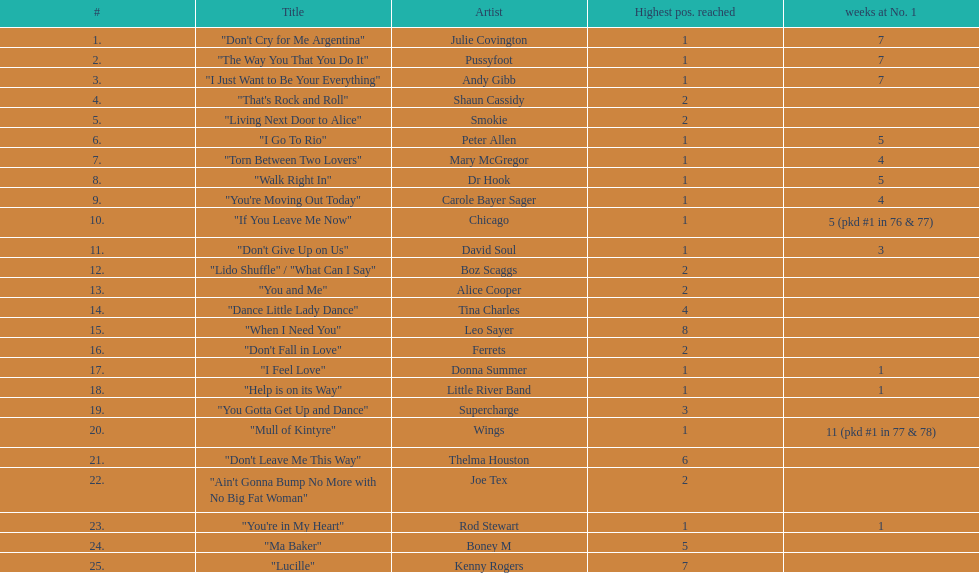Which three artists had a single at number 1 for at least 7 weeks on the australian singles charts in 1977? Julie Covington, Pussyfoot, Andy Gibb. 